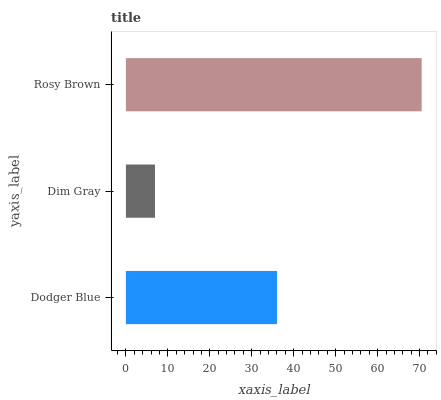Is Dim Gray the minimum?
Answer yes or no. Yes. Is Rosy Brown the maximum?
Answer yes or no. Yes. Is Rosy Brown the minimum?
Answer yes or no. No. Is Dim Gray the maximum?
Answer yes or no. No. Is Rosy Brown greater than Dim Gray?
Answer yes or no. Yes. Is Dim Gray less than Rosy Brown?
Answer yes or no. Yes. Is Dim Gray greater than Rosy Brown?
Answer yes or no. No. Is Rosy Brown less than Dim Gray?
Answer yes or no. No. Is Dodger Blue the high median?
Answer yes or no. Yes. Is Dodger Blue the low median?
Answer yes or no. Yes. Is Dim Gray the high median?
Answer yes or no. No. Is Rosy Brown the low median?
Answer yes or no. No. 